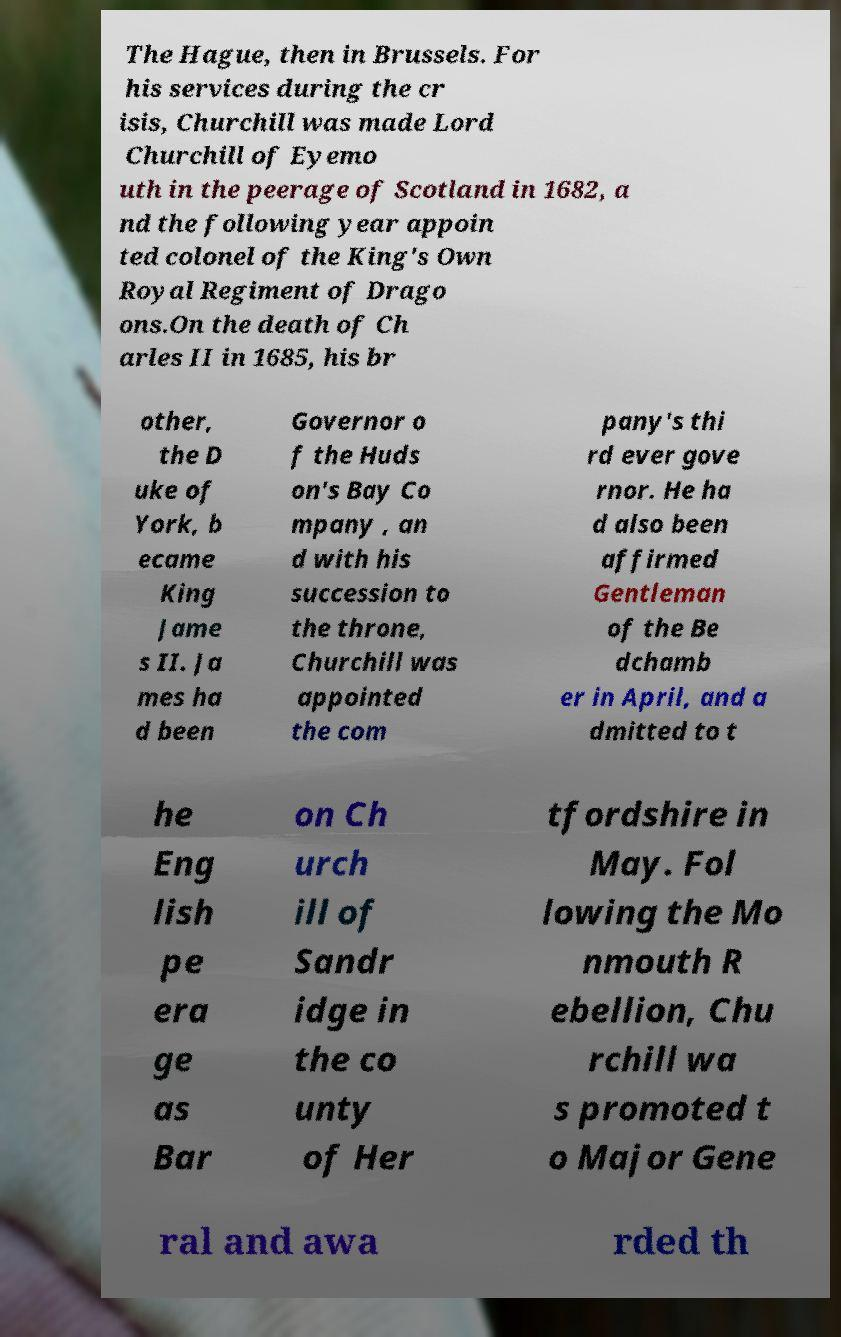Could you extract and type out the text from this image? The Hague, then in Brussels. For his services during the cr isis, Churchill was made Lord Churchill of Eyemo uth in the peerage of Scotland in 1682, a nd the following year appoin ted colonel of the King's Own Royal Regiment of Drago ons.On the death of Ch arles II in 1685, his br other, the D uke of York, b ecame King Jame s II. Ja mes ha d been Governor o f the Huds on's Bay Co mpany , an d with his succession to the throne, Churchill was appointed the com pany's thi rd ever gove rnor. He ha d also been affirmed Gentleman of the Be dchamb er in April, and a dmitted to t he Eng lish pe era ge as Bar on Ch urch ill of Sandr idge in the co unty of Her tfordshire in May. Fol lowing the Mo nmouth R ebellion, Chu rchill wa s promoted t o Major Gene ral and awa rded th 